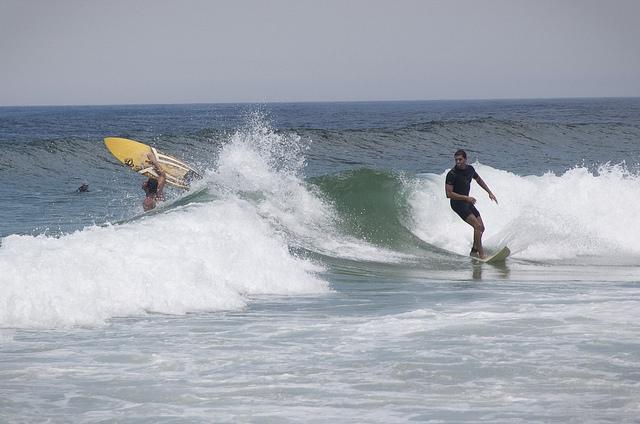How many surfers are in the water?
Give a very brief answer. 2. How many surfboards are in this picture?
Give a very brief answer. 2. How many surfers are there?
Give a very brief answer. 2. How many people are in the water?
Give a very brief answer. 2. How many surfboards are in the water?
Give a very brief answer. 2. How many people are surfing?
Give a very brief answer. 2. How many cars are shown?
Give a very brief answer. 0. 